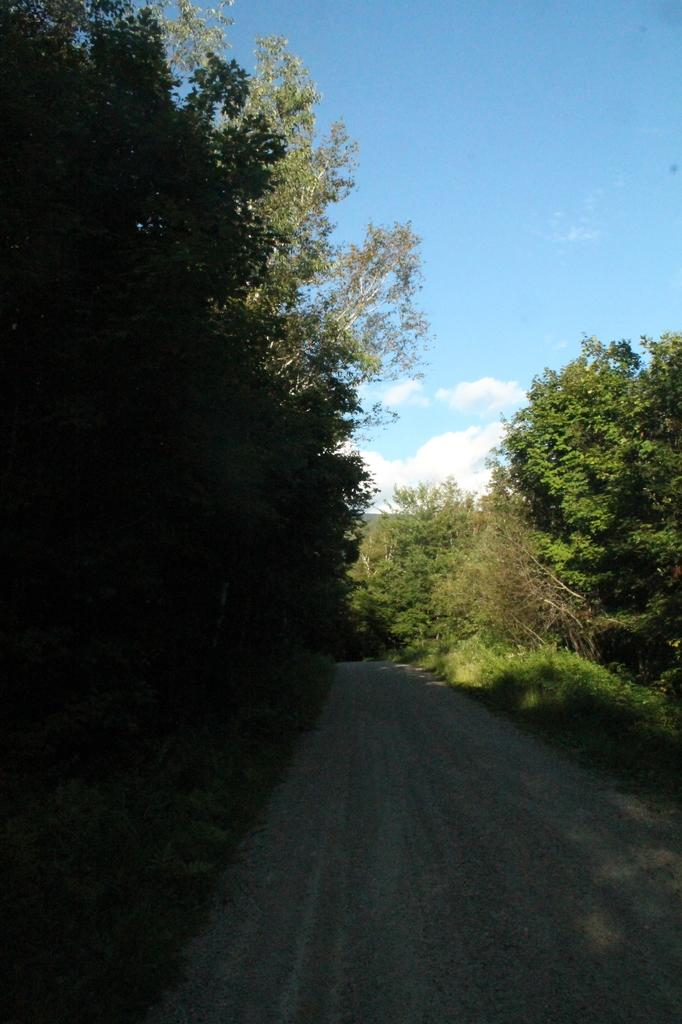What is the main feature of the image? There is a road in the image. What can be seen on both sides of the road? Trees are present on both sides of the road. What is visible in the sky in the background of the image? There are clouds visible in the sky in the background of the image. What is the stranger writing on the road in the image? There is no stranger present in the image, and therefore no writing on the road can be observed. 